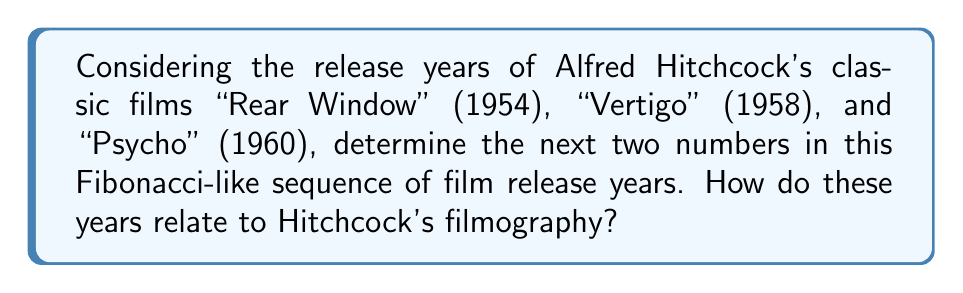Can you answer this question? To solve this problem, we need to understand the Fibonacci sequence and apply it to the given film release years:

1. Identify the pattern:
   1954 (Rear Window)
   1958 (Vertigo)
   1960 (Psycho)

2. Check if it follows the Fibonacci rule:
   In a Fibonacci sequence, each number is the sum of the two preceding ones.
   $1958 - 1954 = 4$
   $1960 - 1958 = 2$
   
   We can see that this doesn't follow the standard Fibonacci rule.

3. Determine the actual relationship:
   $1960 = 1958 + 2$
   $1958 = 1954 + 4$

   The pattern seems to be: add 4, then add 2.

4. Continue the sequence:
   Next number: $1960 + 4 = 1964$
   Following number: $1964 + 2 = 1966$

5. Relating to Hitchcock's filmography:
   1964: Release year of "Marnie"
   1966: Release year of "Torn Curtain"

This sequence, while not a true Fibonacci sequence, follows a pattern that coincidentally aligns with some of Hitchcock's most notable works, reinforcing the classic nature of his filmography without resorting to experimental narrative techniques.
Answer: 1964 and 1966 